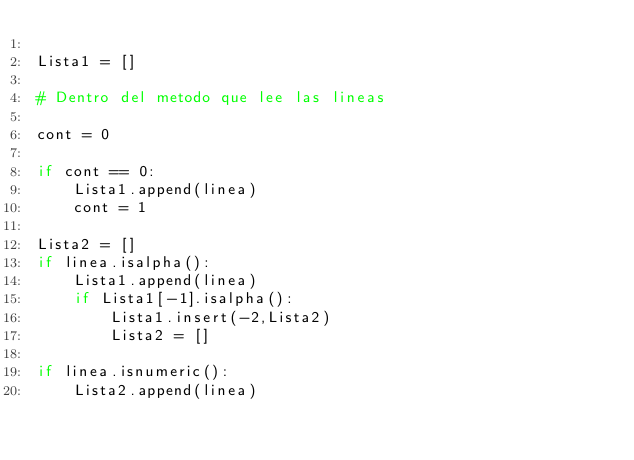<code> <loc_0><loc_0><loc_500><loc_500><_Python_>
Lista1 = []

# Dentro del metodo que lee las lineas 

cont = 0

if cont == 0:
	Lista1.append(linea)
	cont = 1

Lista2 = []
if linea.isalpha():
	Lista1.append(linea)
	if Lista1[-1].isalpha():
		Lista1.insert(-2,Lista2)
		Lista2 = []

if linea.isnumeric():
    Lista2.append(linea)




</code> 